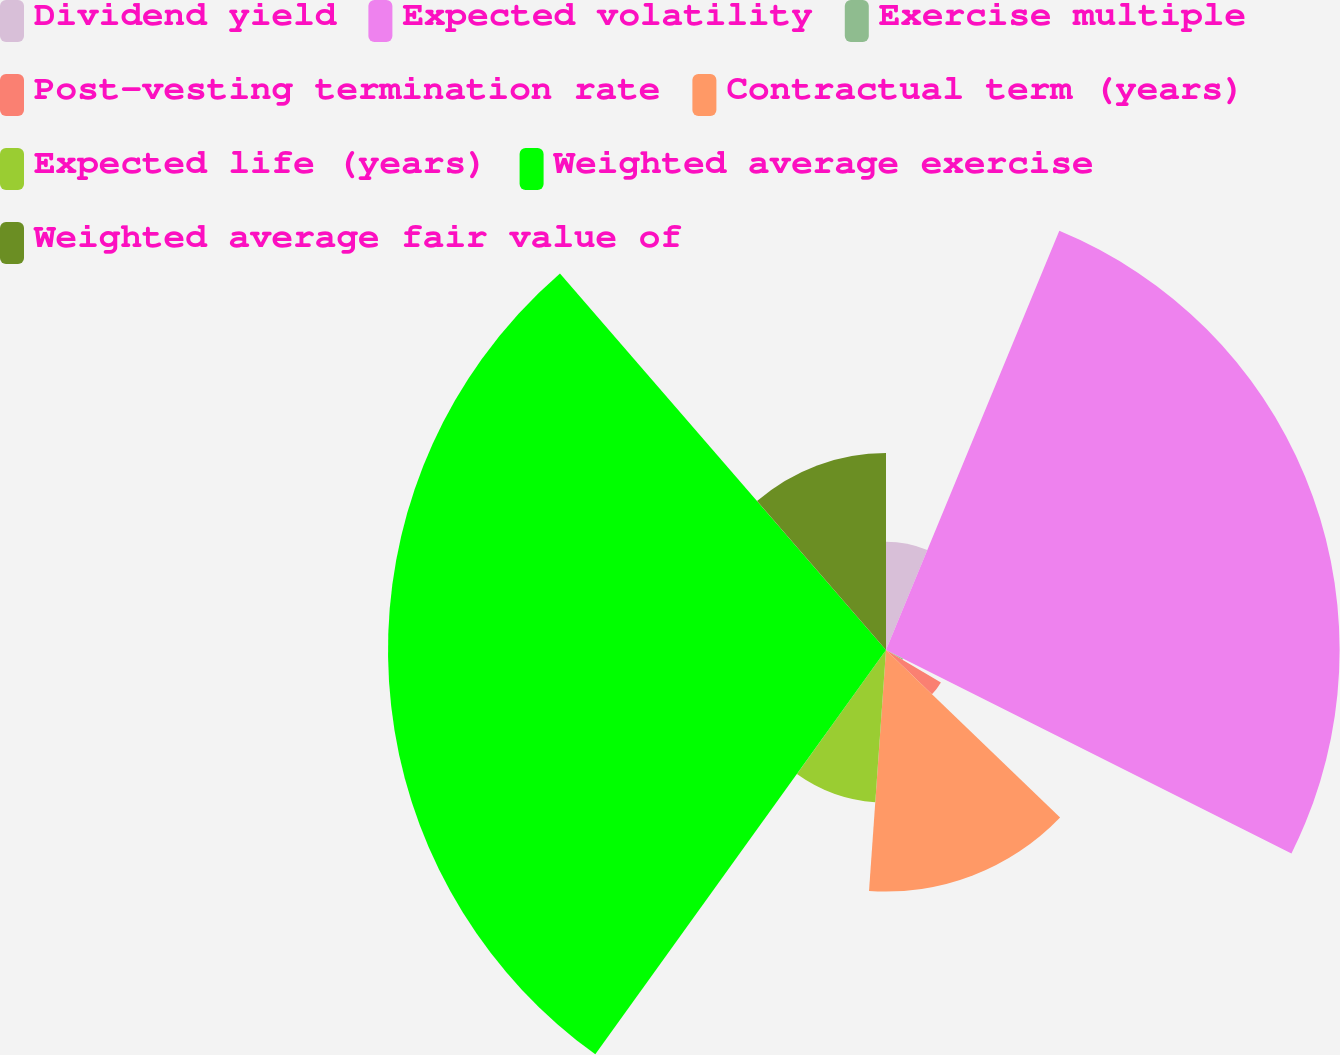<chart> <loc_0><loc_0><loc_500><loc_500><pie_chart><fcel>Dividend yield<fcel>Expected volatility<fcel>Exercise multiple<fcel>Post-vesting termination rate<fcel>Contractual term (years)<fcel>Expected life (years)<fcel>Weighted average exercise<fcel>Weighted average fair value of<nl><fcel>6.24%<fcel>26.16%<fcel>1.11%<fcel>3.68%<fcel>13.93%<fcel>8.8%<fcel>28.72%<fcel>11.36%<nl></chart> 